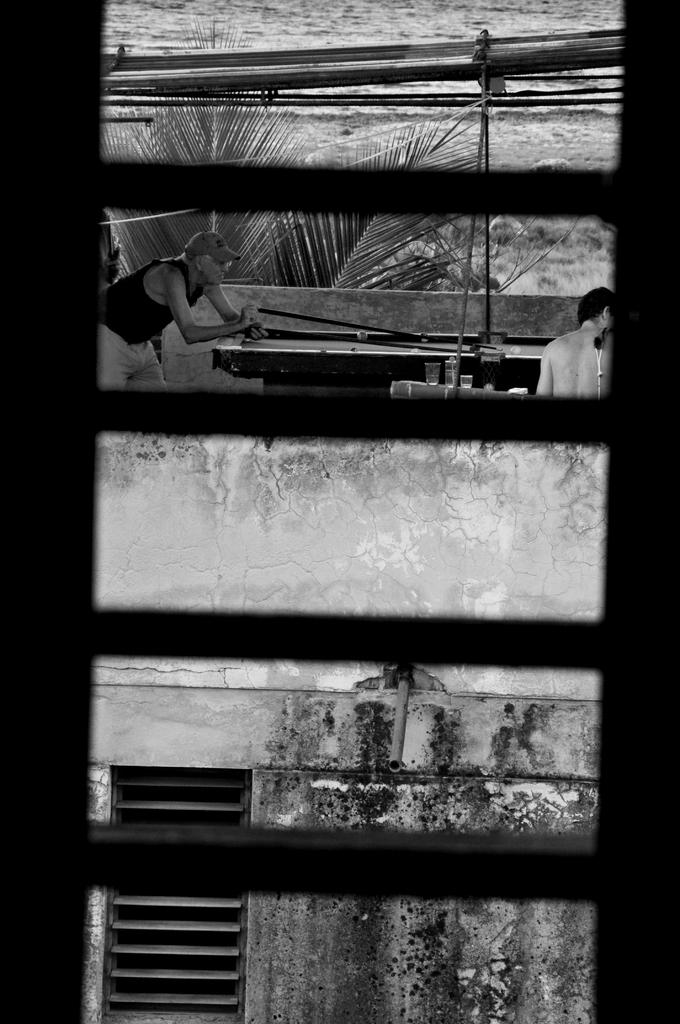Who is present in the image? There is a man in the image. Can you describe the person in the image? There is a person in the image, which is the man. What is in the background of the image? There is a building in the image. What is the color scheme of the image? The image is black and white in color. What natural element can be seen in the image? There is water visible in the image. Can you tell me how many kittens are playing on the grass in the image? There are no kittens or grass present in the image; it is a black and white image featuring a man, a building, and water. 